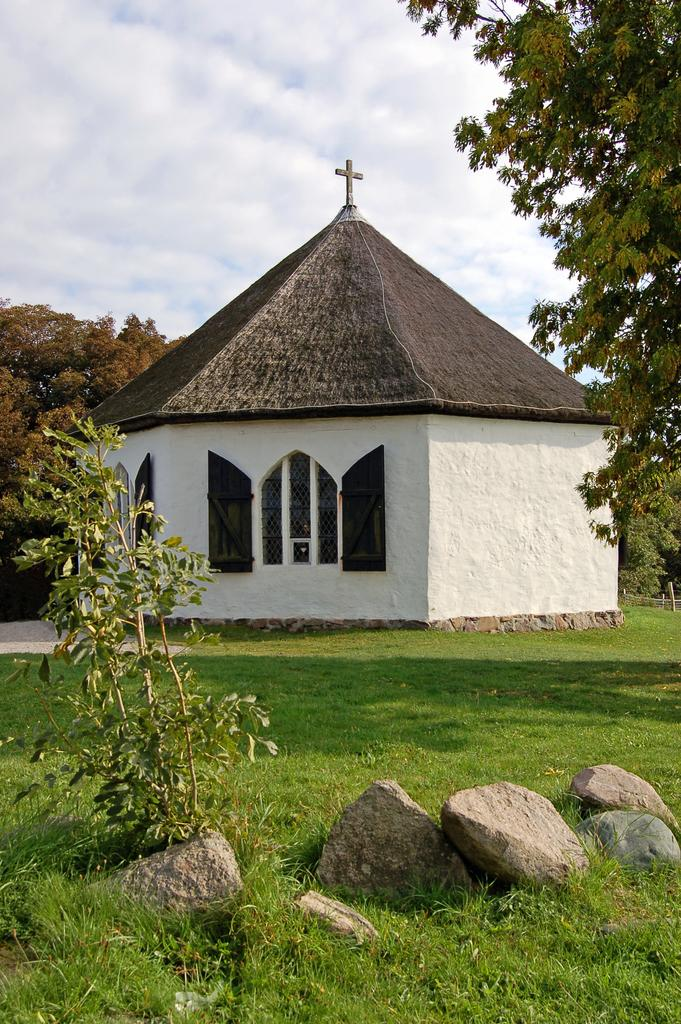What type of structure is present in the image? There is a building in the image. What type of vegetation can be seen in the image? There is green grass and plants in the image. What other objects can be seen in the image? There are stones in the image. What can be seen in the background of the image? There are trees and the sky visible in the background of the image. How many sheep are grazing in the grass in the image? There are no sheep present in the image. What type of church can be seen in the background of the image? There is no church present in the image; only trees and the sky are visible in the background. 